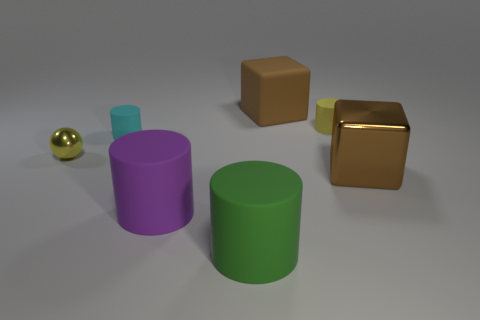What number of small metal balls are on the right side of the tiny yellow thing that is right of the cyan matte cylinder? There are no small metal balls on the right side of the tiny yellow object that is positioned to the right of the cyan matte cylinder. 